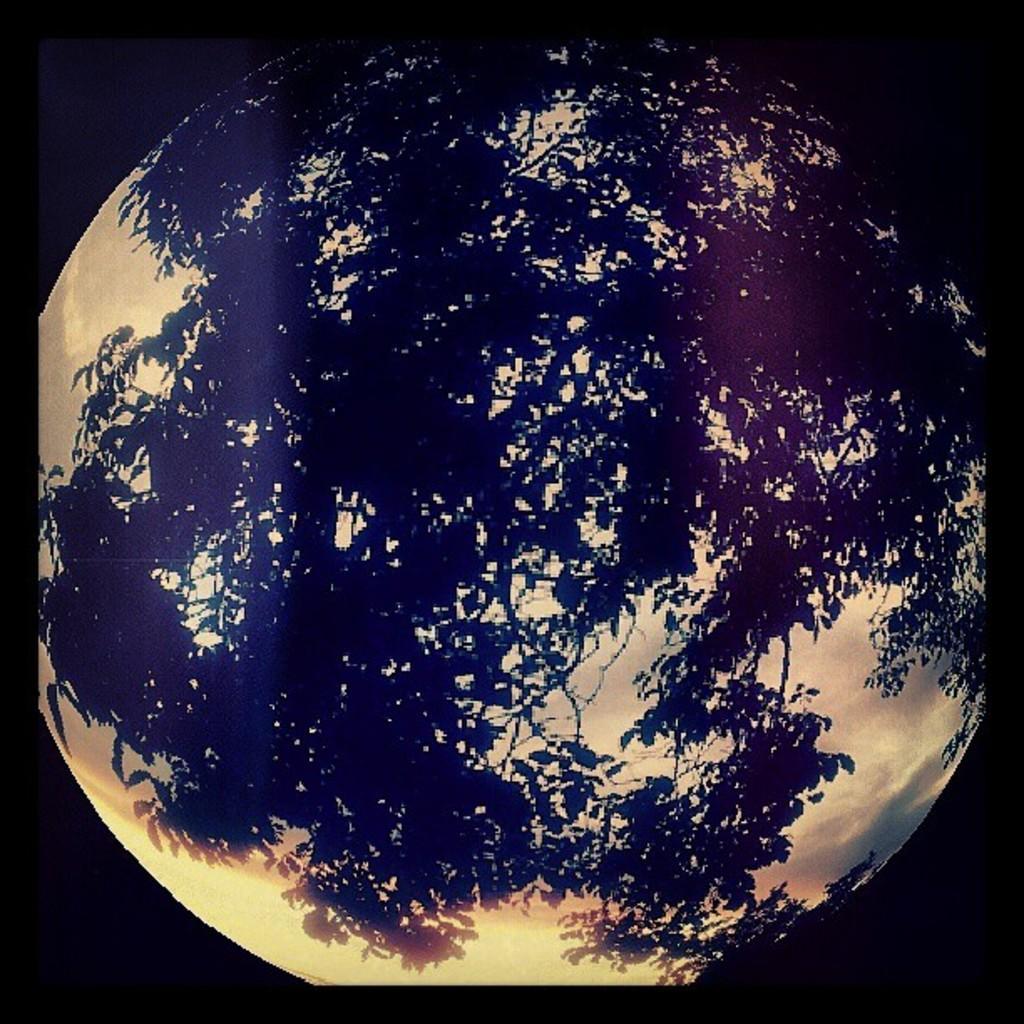In one or two sentences, can you explain what this image depicts? As we can see in the image there is a tree reflection. 